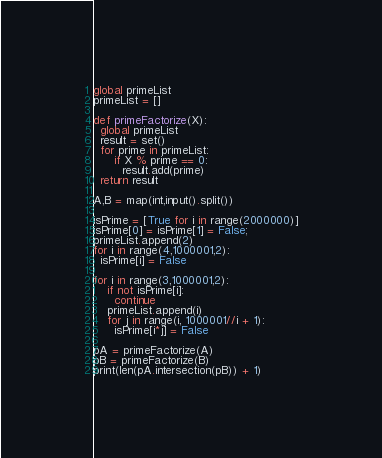Convert code to text. <code><loc_0><loc_0><loc_500><loc_500><_Python_>global primeList
primeList = []

def primeFactorize(X):
  global primeList
  result = set()
  for prime in primeList:
      if X % prime == 0:
        result.add(prime)
  return result

A,B = map(int,input().split())

isPrime = [True for i in range(2000000)]
isPrime[0] = isPrime[1] = False;
primeList.append(2)
for i in range(4,1000001,2):
  isPrime[i] = False

for i in range(3,1000001,2):
    if not isPrime[i]:
      continue
    primeList.append(i)
    for j in range(i, 1000001//i + 1):
      isPrime[i*j] = False

pA = primeFactorize(A)
pB = primeFactorize(B)
print(len(pA.intersection(pB)) + 1)


</code> 